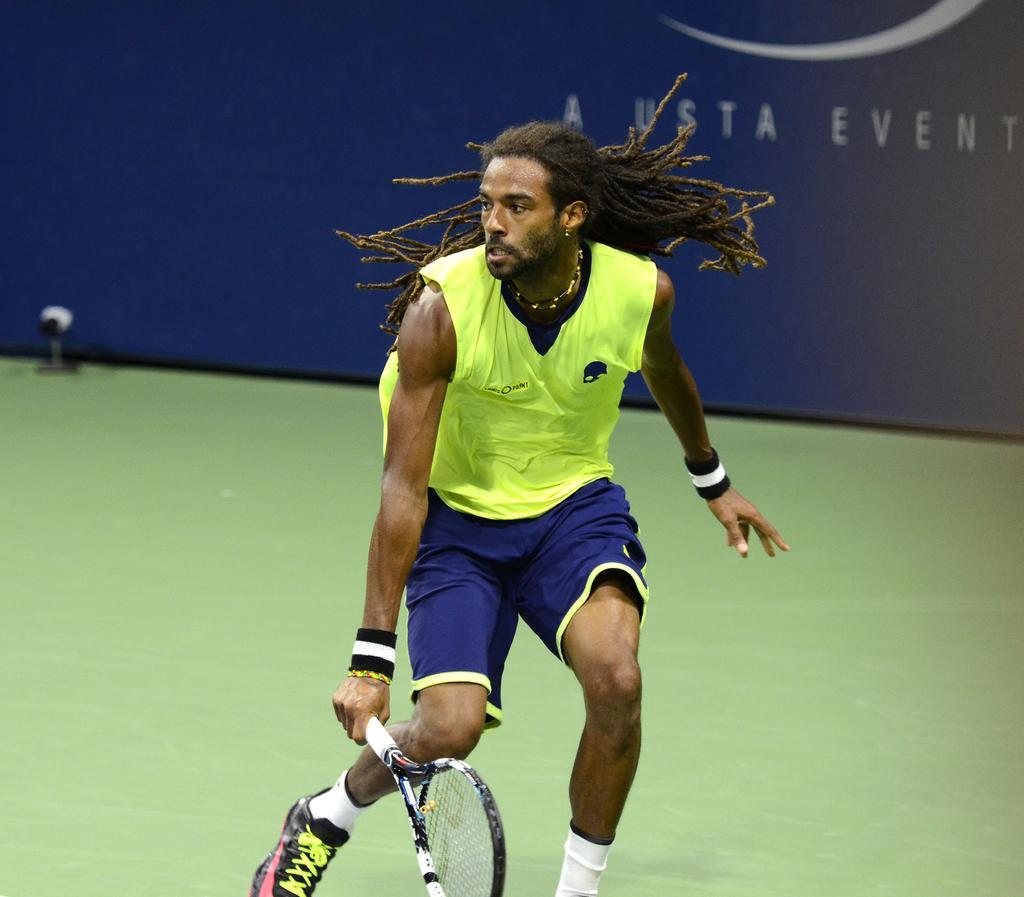Can you describe this image briefly? This is a hoarding. We can see one man with long hair. He wore wrist bands and he is holding a tennis racket in his hand. This is a floor. 